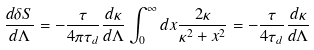Convert formula to latex. <formula><loc_0><loc_0><loc_500><loc_500>\frac { d \delta S } { d { \Lambda } } = - \frac { \tau } { 4 \pi \tau _ { d } } \frac { d \kappa } { d { \Lambda } } \int _ { 0 } ^ { \infty } d x \frac { 2 \kappa } { \kappa ^ { 2 } + x ^ { 2 } } = - \frac { \tau } { 4 \tau _ { d } } \frac { d \kappa } { d { \Lambda } }</formula> 